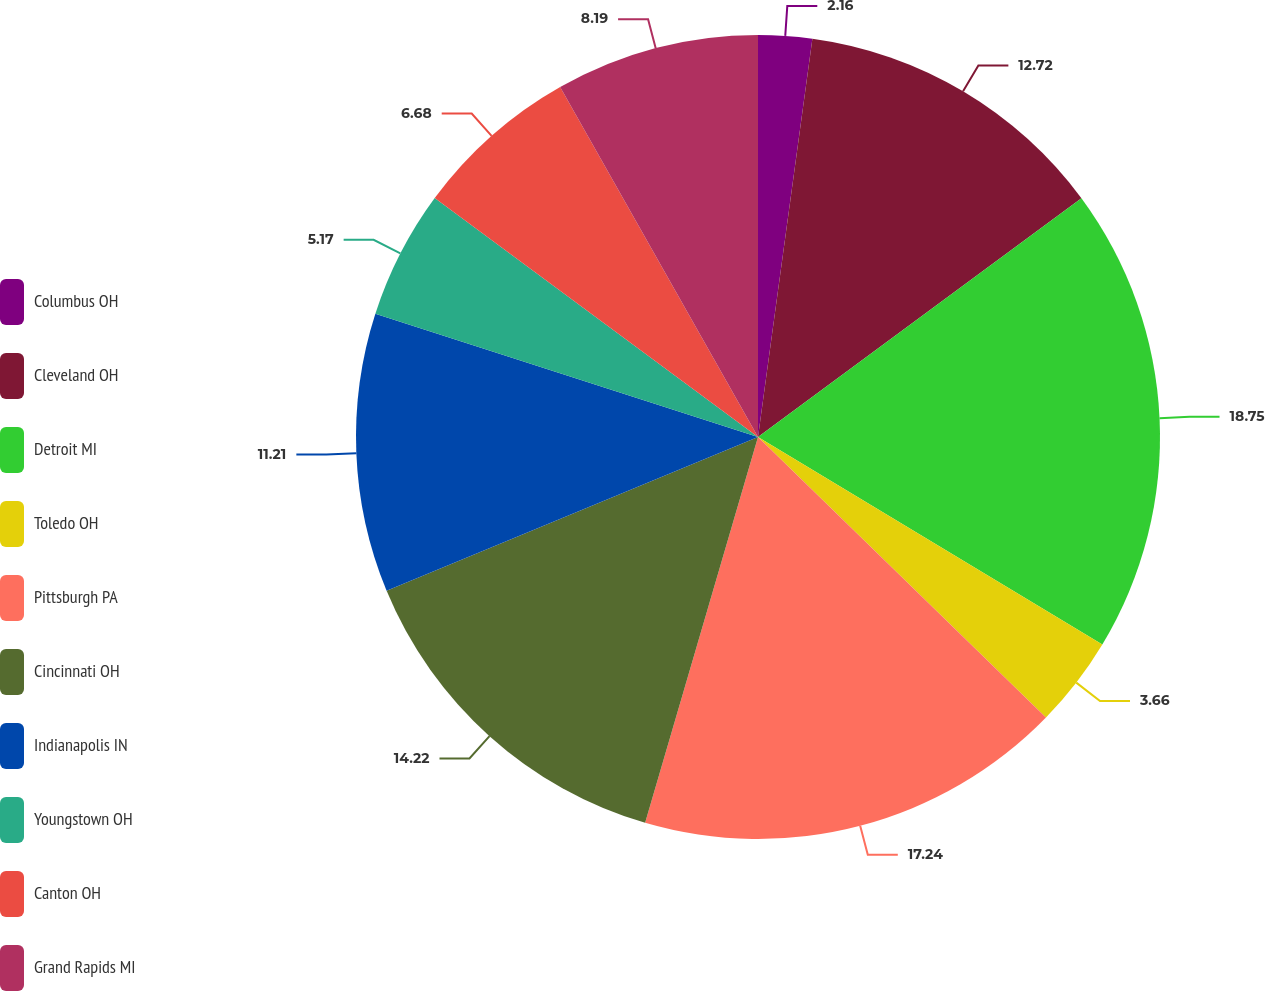Convert chart. <chart><loc_0><loc_0><loc_500><loc_500><pie_chart><fcel>Columbus OH<fcel>Cleveland OH<fcel>Detroit MI<fcel>Toledo OH<fcel>Pittsburgh PA<fcel>Cincinnati OH<fcel>Indianapolis IN<fcel>Youngstown OH<fcel>Canton OH<fcel>Grand Rapids MI<nl><fcel>2.16%<fcel>12.72%<fcel>18.75%<fcel>3.66%<fcel>17.24%<fcel>14.22%<fcel>11.21%<fcel>5.17%<fcel>6.68%<fcel>8.19%<nl></chart> 